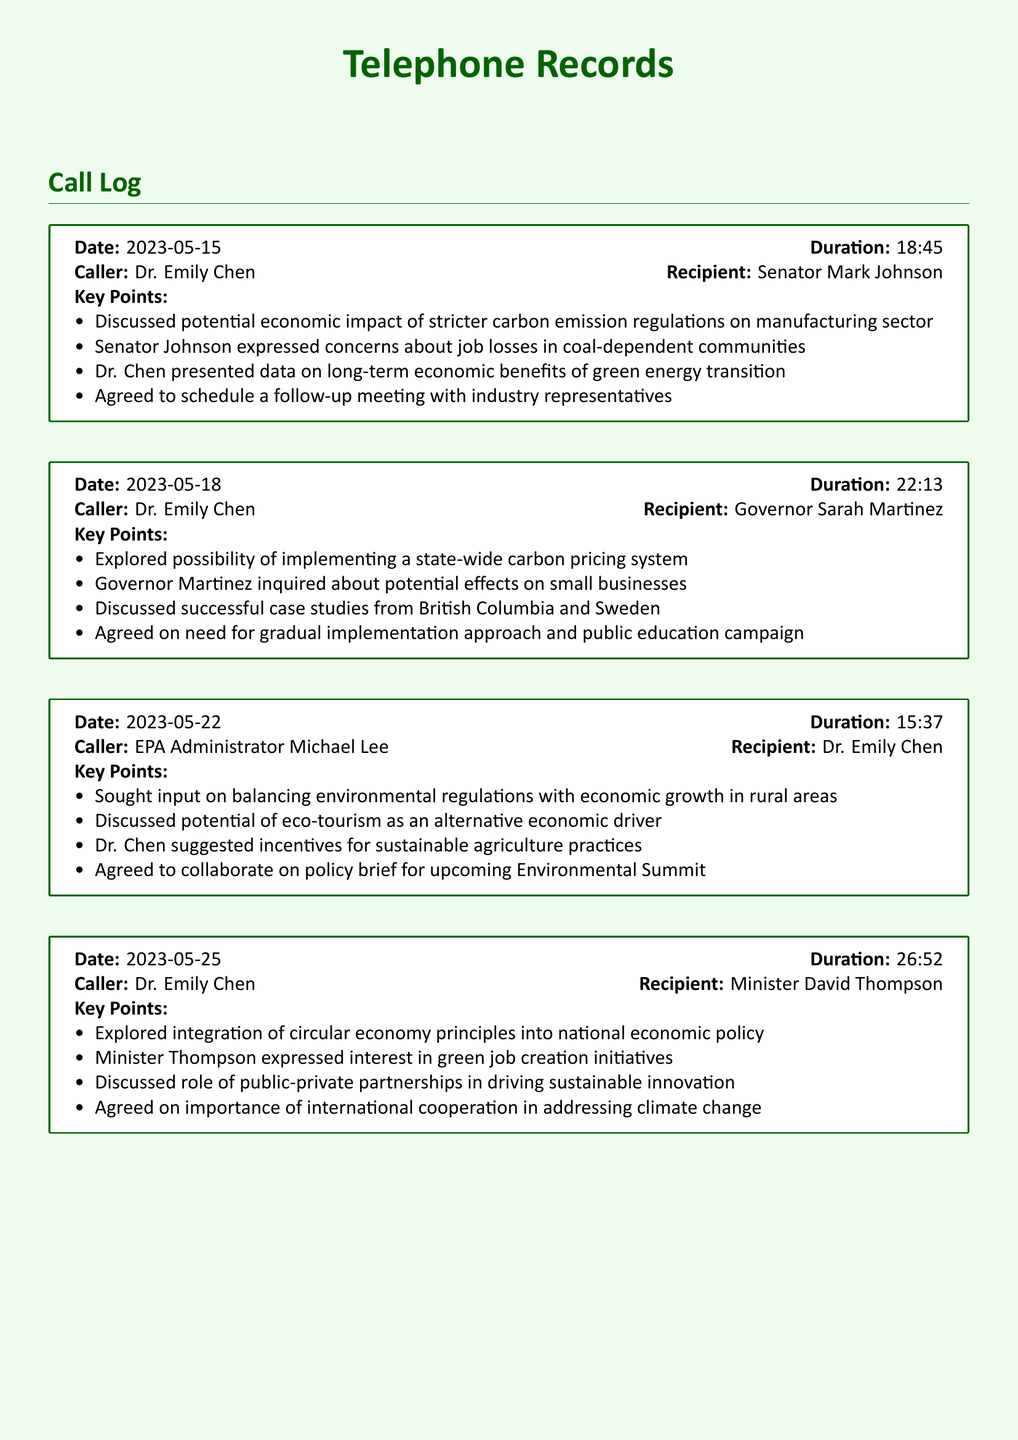What date was the call with Senator Mark Johnson? The date of the call is mentioned at the beginning of the entry, which is 2023-05-15.
Answer: 2023-05-15 Who called Governor Sarah Martinez? The caller's name is indicated in the entry, which is Dr. Emily Chen.
Answer: Dr. Emily Chen What was a key point discussed during the call with EPA Administrator Michael Lee? The key points are listed in the document; one of them is balancing environmental regulations with economic growth in rural areas.
Answer: Balancing environmental regulations with economic growth in rural areas How long was the call with Minister David Thompson? The duration of the call is provided in the entry, which is 26:52.
Answer: 26:52 What economic approach did Dr. Chen suggest during the call with Senator Johnson? The document states that Dr. Chen presented data on long-term economic benefits of green energy transition.
Answer: Green energy transition What principle was discussed for integration into national economic policy? The principle mentioned in the call with Minister Thompson is circular economy principles.
Answer: Circular economy principles What is one effect discussed regarding small businesses? According to the document, Governor Martinez inquired about potential effects of a state-wide carbon pricing system on small businesses.
Answer: Potential effects on small businesses What collaborative document was agreed upon during the call with EPA Administrator Michael Lee? The document states that they agreed to collaborate on a policy brief for an upcoming Environmental Summit.
Answer: Policy brief for upcoming Environmental Summit What type of career initiatives was discussed with Minister David Thompson? The discussion included green job creation initiatives.
Answer: Green job creation initiatives 